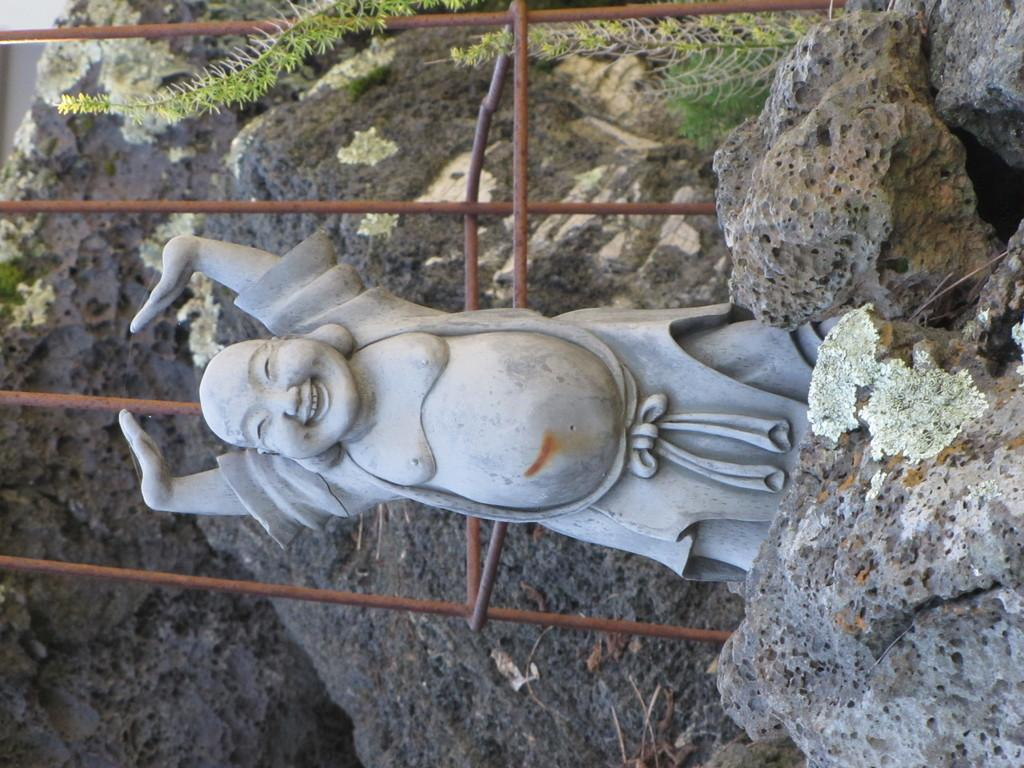What figure is present in the image? There is a laughing Buddha in the image. What is the laughing Buddha positioned in front of? The laughing Buddha is in front of rods. What type of natural elements can be seen on the right side of the image? There are rocks on the right side of the image. What type of linen is draped over the laughing Buddha in the image? There is no linen draped over the laughing Buddha in the image. How does the laughing Buddha attract the attention of passersby in the image? The image does not show the laughing Buddha attracting the attention of passersby, so we cannot determine how it might do so. 